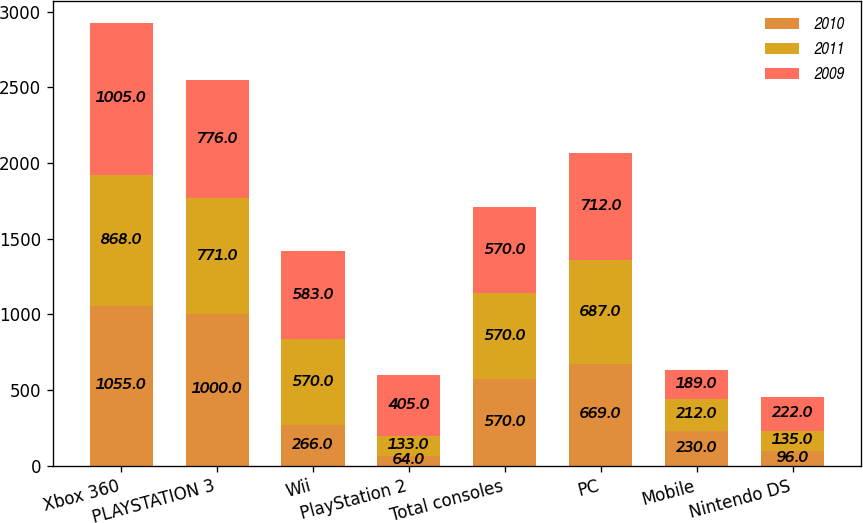<chart> <loc_0><loc_0><loc_500><loc_500><stacked_bar_chart><ecel><fcel>Xbox 360<fcel>PLAYSTATION 3<fcel>Wii<fcel>PlayStation 2<fcel>Total consoles<fcel>PC<fcel>Mobile<fcel>Nintendo DS<nl><fcel>2010<fcel>1055<fcel>1000<fcel>266<fcel>64<fcel>570<fcel>669<fcel>230<fcel>96<nl><fcel>2011<fcel>868<fcel>771<fcel>570<fcel>133<fcel>570<fcel>687<fcel>212<fcel>135<nl><fcel>2009<fcel>1005<fcel>776<fcel>583<fcel>405<fcel>570<fcel>712<fcel>189<fcel>222<nl></chart> 